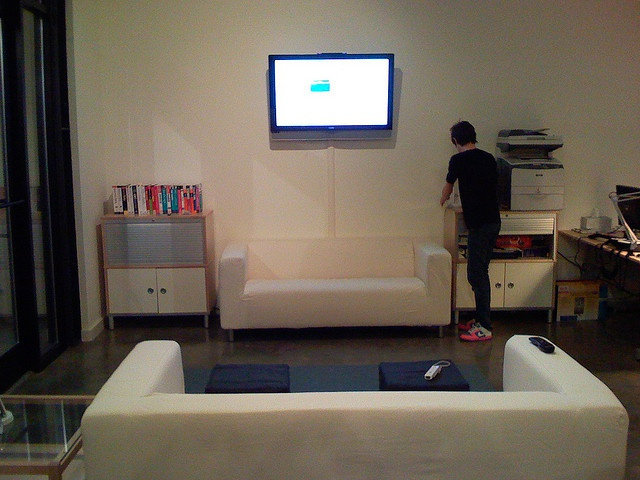Describe the objects in this image and their specific colors. I can see couch in black, gray, and darkgray tones, couch in black, gray, tan, and darkgray tones, tv in black, white, navy, darkblue, and blue tones, people in black, gray, and maroon tones, and remote in black, navy, and blue tones in this image. 